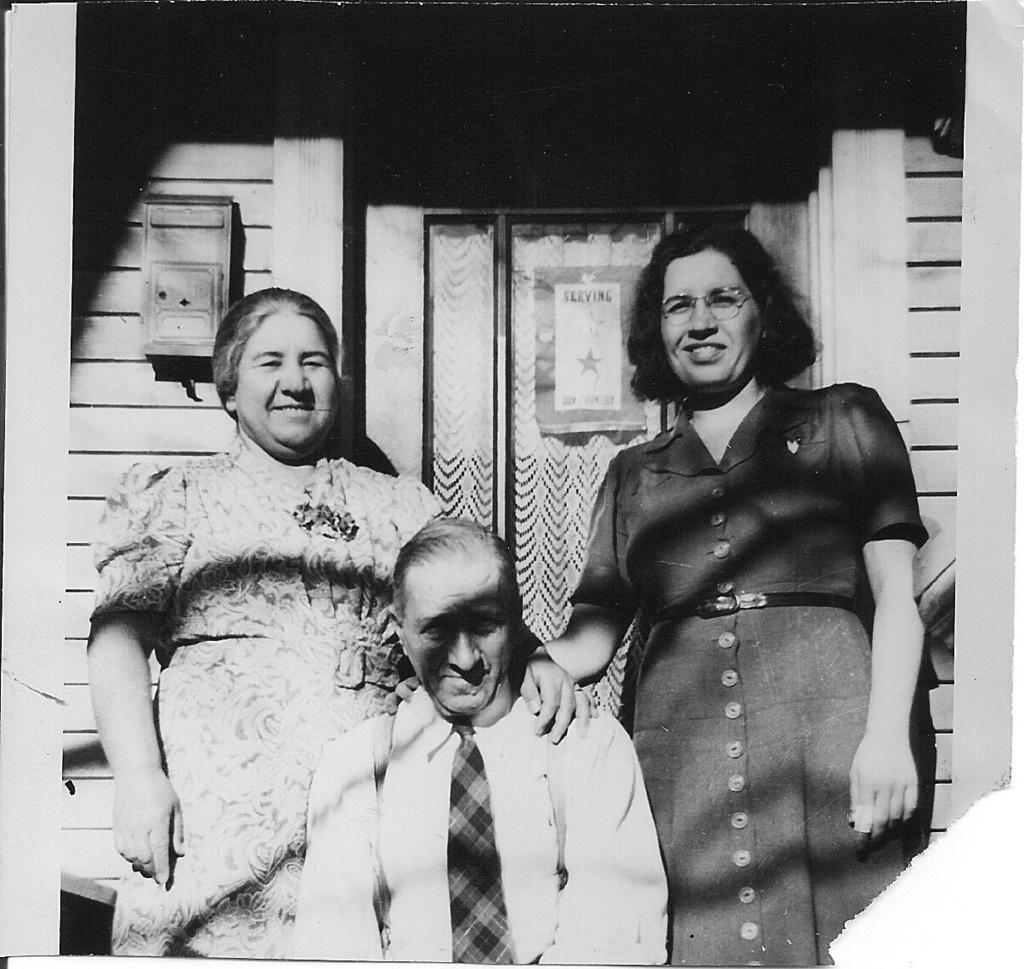In one or two sentences, can you explain what this image depicts? In this picture there is a door in the center of the image and there two ladies on the right and left side of the image and there is a door behind them and there is a box on the left side of the image. 